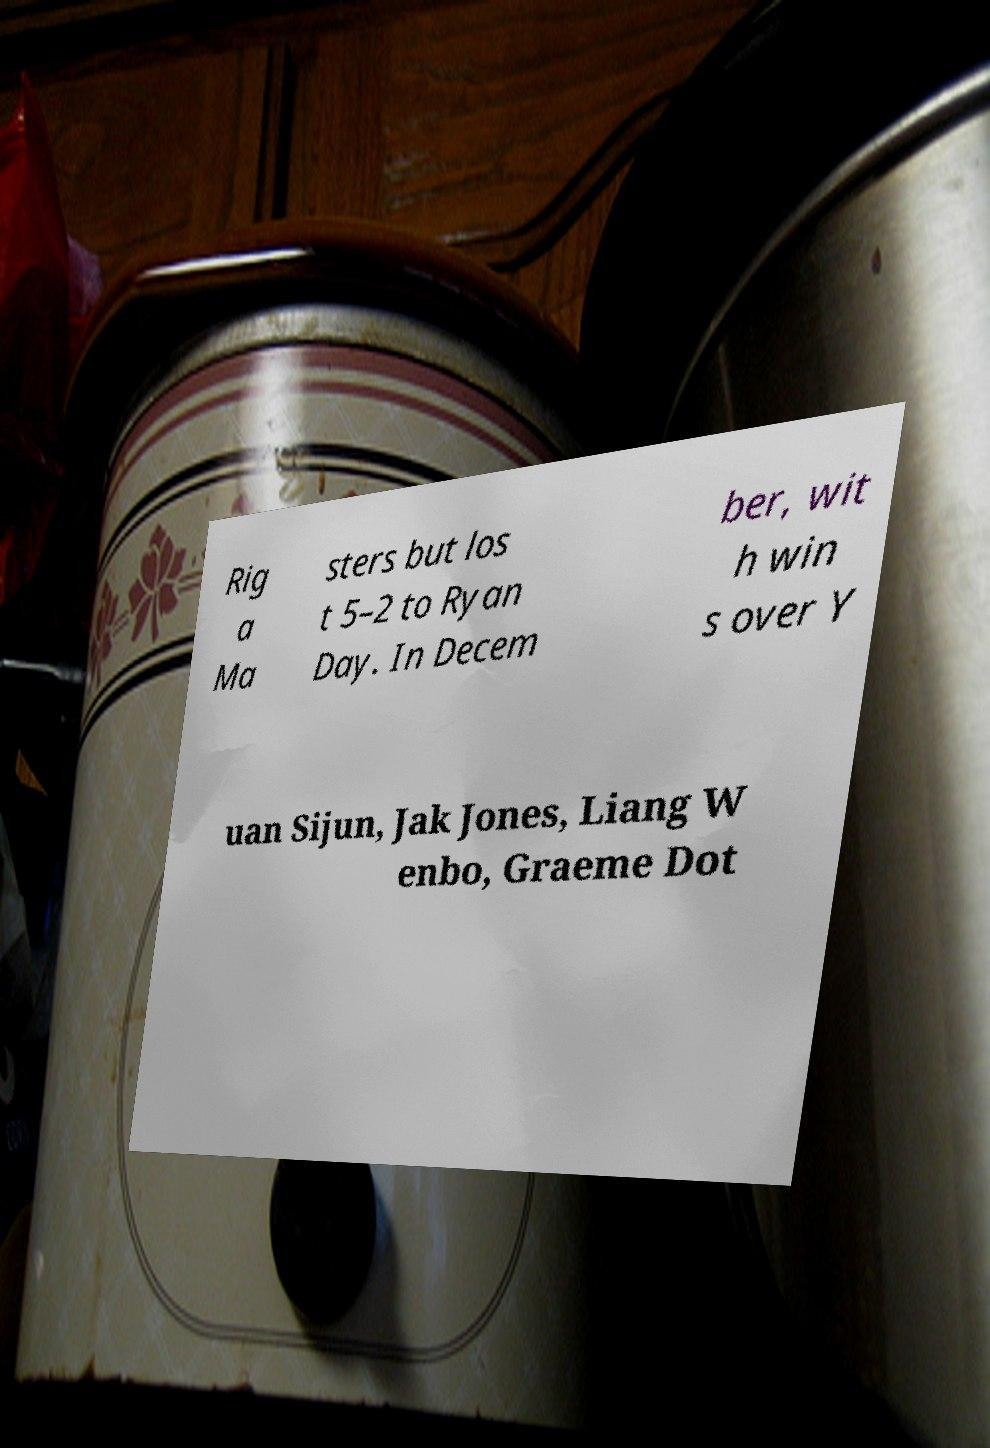For documentation purposes, I need the text within this image transcribed. Could you provide that? Rig a Ma sters but los t 5–2 to Ryan Day. In Decem ber, wit h win s over Y uan Sijun, Jak Jones, Liang W enbo, Graeme Dot 